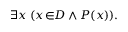<formula> <loc_0><loc_0><loc_500><loc_500>\exists x \, ( x \, \in \, D \land P ( x ) ) .</formula> 